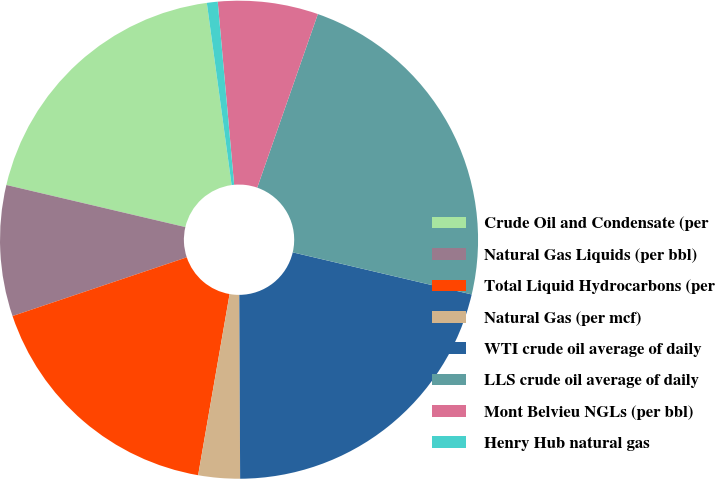<chart> <loc_0><loc_0><loc_500><loc_500><pie_chart><fcel>Crude Oil and Condensate (per<fcel>Natural Gas Liquids (per bbl)<fcel>Total Liquid Hydrocarbons (per<fcel>Natural Gas (per mcf)<fcel>WTI crude oil average of daily<fcel>LLS crude oil average of daily<fcel>Mont Belvieu NGLs (per bbl)<fcel>Henry Hub natural gas<nl><fcel>19.17%<fcel>8.85%<fcel>17.09%<fcel>2.81%<fcel>21.25%<fcel>23.33%<fcel>6.77%<fcel>0.73%<nl></chart> 